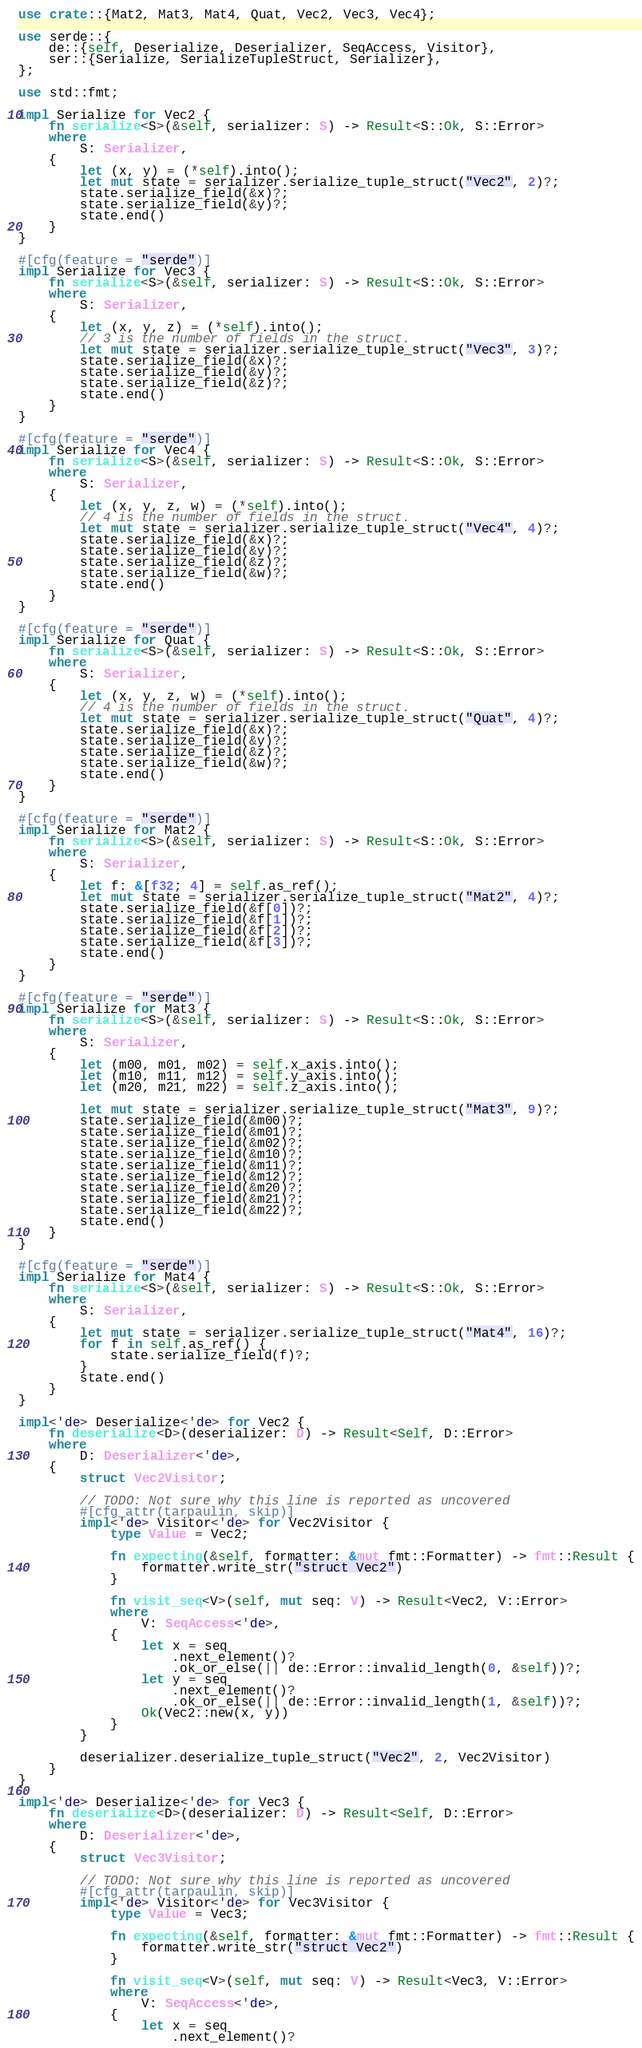<code> <loc_0><loc_0><loc_500><loc_500><_Rust_>use crate::{Mat2, Mat3, Mat4, Quat, Vec2, Vec3, Vec4};

use serde::{
    de::{self, Deserialize, Deserializer, SeqAccess, Visitor},
    ser::{Serialize, SerializeTupleStruct, Serializer},
};

use std::fmt;

impl Serialize for Vec2 {
    fn serialize<S>(&self, serializer: S) -> Result<S::Ok, S::Error>
    where
        S: Serializer,
    {
        let (x, y) = (*self).into();
        let mut state = serializer.serialize_tuple_struct("Vec2", 2)?;
        state.serialize_field(&x)?;
        state.serialize_field(&y)?;
        state.end()
    }
}

#[cfg(feature = "serde")]
impl Serialize for Vec3 {
    fn serialize<S>(&self, serializer: S) -> Result<S::Ok, S::Error>
    where
        S: Serializer,
    {
        let (x, y, z) = (*self).into();
        // 3 is the number of fields in the struct.
        let mut state = serializer.serialize_tuple_struct("Vec3", 3)?;
        state.serialize_field(&x)?;
        state.serialize_field(&y)?;
        state.serialize_field(&z)?;
        state.end()
    }
}

#[cfg(feature = "serde")]
impl Serialize for Vec4 {
    fn serialize<S>(&self, serializer: S) -> Result<S::Ok, S::Error>
    where
        S: Serializer,
    {
        let (x, y, z, w) = (*self).into();
        // 4 is the number of fields in the struct.
        let mut state = serializer.serialize_tuple_struct("Vec4", 4)?;
        state.serialize_field(&x)?;
        state.serialize_field(&y)?;
        state.serialize_field(&z)?;
        state.serialize_field(&w)?;
        state.end()
    }
}

#[cfg(feature = "serde")]
impl Serialize for Quat {
    fn serialize<S>(&self, serializer: S) -> Result<S::Ok, S::Error>
    where
        S: Serializer,
    {
        let (x, y, z, w) = (*self).into();
        // 4 is the number of fields in the struct.
        let mut state = serializer.serialize_tuple_struct("Quat", 4)?;
        state.serialize_field(&x)?;
        state.serialize_field(&y)?;
        state.serialize_field(&z)?;
        state.serialize_field(&w)?;
        state.end()
    }
}

#[cfg(feature = "serde")]
impl Serialize for Mat2 {
    fn serialize<S>(&self, serializer: S) -> Result<S::Ok, S::Error>
    where
        S: Serializer,
    {
        let f: &[f32; 4] = self.as_ref();
        let mut state = serializer.serialize_tuple_struct("Mat2", 4)?;
        state.serialize_field(&f[0])?;
        state.serialize_field(&f[1])?;
        state.serialize_field(&f[2])?;
        state.serialize_field(&f[3])?;
        state.end()
    }
}

#[cfg(feature = "serde")]
impl Serialize for Mat3 {
    fn serialize<S>(&self, serializer: S) -> Result<S::Ok, S::Error>
    where
        S: Serializer,
    {
        let (m00, m01, m02) = self.x_axis.into();
        let (m10, m11, m12) = self.y_axis.into();
        let (m20, m21, m22) = self.z_axis.into();

        let mut state = serializer.serialize_tuple_struct("Mat3", 9)?;
        state.serialize_field(&m00)?;
        state.serialize_field(&m01)?;
        state.serialize_field(&m02)?;
        state.serialize_field(&m10)?;
        state.serialize_field(&m11)?;
        state.serialize_field(&m12)?;
        state.serialize_field(&m20)?;
        state.serialize_field(&m21)?;
        state.serialize_field(&m22)?;
        state.end()
    }
}

#[cfg(feature = "serde")]
impl Serialize for Mat4 {
    fn serialize<S>(&self, serializer: S) -> Result<S::Ok, S::Error>
    where
        S: Serializer,
    {
        let mut state = serializer.serialize_tuple_struct("Mat4", 16)?;
        for f in self.as_ref() {
            state.serialize_field(f)?;
        }
        state.end()
    }
}

impl<'de> Deserialize<'de> for Vec2 {
    fn deserialize<D>(deserializer: D) -> Result<Self, D::Error>
    where
        D: Deserializer<'de>,
    {
        struct Vec2Visitor;

        // TODO: Not sure why this line is reported as uncovered
        #[cfg_attr(tarpaulin, skip)]
        impl<'de> Visitor<'de> for Vec2Visitor {
            type Value = Vec2;

            fn expecting(&self, formatter: &mut fmt::Formatter) -> fmt::Result {
                formatter.write_str("struct Vec2")
            }

            fn visit_seq<V>(self, mut seq: V) -> Result<Vec2, V::Error>
            where
                V: SeqAccess<'de>,
            {
                let x = seq
                    .next_element()?
                    .ok_or_else(|| de::Error::invalid_length(0, &self))?;
                let y = seq
                    .next_element()?
                    .ok_or_else(|| de::Error::invalid_length(1, &self))?;
                Ok(Vec2::new(x, y))
            }
        }

        deserializer.deserialize_tuple_struct("Vec2", 2, Vec2Visitor)
    }
}

impl<'de> Deserialize<'de> for Vec3 {
    fn deserialize<D>(deserializer: D) -> Result<Self, D::Error>
    where
        D: Deserializer<'de>,
    {
        struct Vec3Visitor;

        // TODO: Not sure why this line is reported as uncovered
        #[cfg_attr(tarpaulin, skip)]
        impl<'de> Visitor<'de> for Vec3Visitor {
            type Value = Vec3;

            fn expecting(&self, formatter: &mut fmt::Formatter) -> fmt::Result {
                formatter.write_str("struct Vec2")
            }

            fn visit_seq<V>(self, mut seq: V) -> Result<Vec3, V::Error>
            where
                V: SeqAccess<'de>,
            {
                let x = seq
                    .next_element()?</code> 